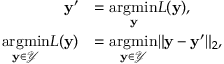Convert formula to latex. <formula><loc_0><loc_0><loc_500><loc_500>\begin{array} { r l } { y ^ { \prime } } & { = \underset { y } { \arg \min } L ( y ) , } \\ { \underset { y \in \mathcal { Y } } { \arg \min } L ( y ) } & { = \underset { y \in \mathcal { Y } } { \arg \min } \| y - y ^ { \prime } \| _ { 2 } , } \end{array}</formula> 